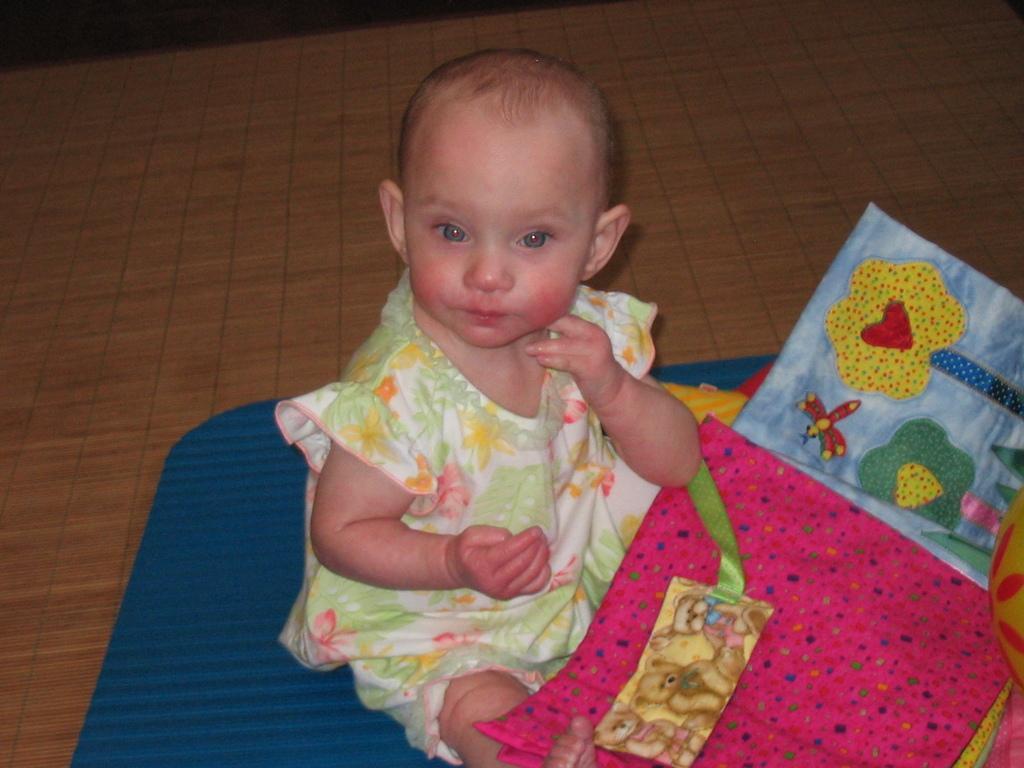Describe this image in one or two sentences. In this image there is a girl sitting, there are clothes towards the bottom of the image, there is an object towards the right of the image, there is a wooden floor. 